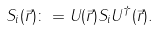Convert formula to latex. <formula><loc_0><loc_0><loc_500><loc_500>S _ { i } ( \vec { r } ) \colon = U ( \vec { r } ) S _ { i } U ^ { \dagger } ( \vec { r } ) .</formula> 